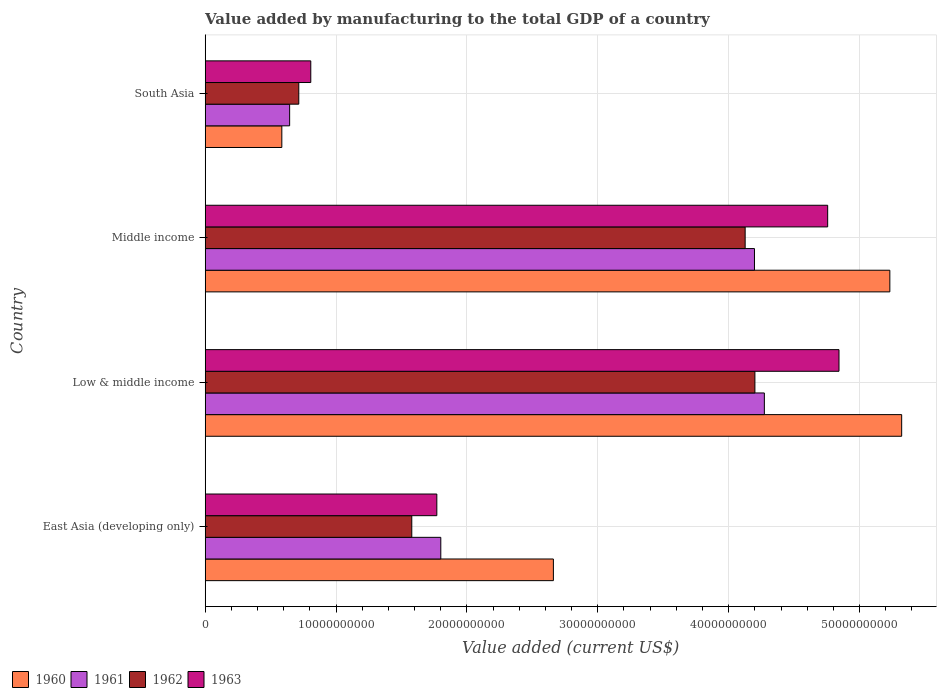How many groups of bars are there?
Your response must be concise. 4. Are the number of bars on each tick of the Y-axis equal?
Your answer should be very brief. Yes. What is the label of the 4th group of bars from the top?
Make the answer very short. East Asia (developing only). What is the value added by manufacturing to the total GDP in 1962 in Middle income?
Provide a succinct answer. 4.13e+1. Across all countries, what is the maximum value added by manufacturing to the total GDP in 1961?
Provide a short and direct response. 4.27e+1. Across all countries, what is the minimum value added by manufacturing to the total GDP in 1961?
Offer a very short reply. 6.45e+09. In which country was the value added by manufacturing to the total GDP in 1960 minimum?
Ensure brevity in your answer.  South Asia. What is the total value added by manufacturing to the total GDP in 1963 in the graph?
Your response must be concise. 1.22e+11. What is the difference between the value added by manufacturing to the total GDP in 1961 in Low & middle income and that in Middle income?
Offer a very short reply. 7.56e+08. What is the difference between the value added by manufacturing to the total GDP in 1963 in Middle income and the value added by manufacturing to the total GDP in 1961 in Low & middle income?
Your answer should be compact. 4.84e+09. What is the average value added by manufacturing to the total GDP in 1960 per country?
Keep it short and to the point. 3.45e+1. What is the difference between the value added by manufacturing to the total GDP in 1962 and value added by manufacturing to the total GDP in 1961 in East Asia (developing only)?
Your answer should be very brief. -2.22e+09. What is the ratio of the value added by manufacturing to the total GDP in 1962 in Middle income to that in South Asia?
Your response must be concise. 5.77. What is the difference between the highest and the second highest value added by manufacturing to the total GDP in 1962?
Ensure brevity in your answer.  7.46e+08. What is the difference between the highest and the lowest value added by manufacturing to the total GDP in 1961?
Give a very brief answer. 3.63e+1. Is the sum of the value added by manufacturing to the total GDP in 1961 in Middle income and South Asia greater than the maximum value added by manufacturing to the total GDP in 1963 across all countries?
Your response must be concise. No. Is it the case that in every country, the sum of the value added by manufacturing to the total GDP in 1960 and value added by manufacturing to the total GDP in 1962 is greater than the sum of value added by manufacturing to the total GDP in 1961 and value added by manufacturing to the total GDP in 1963?
Make the answer very short. No. Is it the case that in every country, the sum of the value added by manufacturing to the total GDP in 1962 and value added by manufacturing to the total GDP in 1963 is greater than the value added by manufacturing to the total GDP in 1960?
Your answer should be very brief. Yes. How many countries are there in the graph?
Your answer should be compact. 4. What is the difference between two consecutive major ticks on the X-axis?
Your answer should be very brief. 1.00e+1. Are the values on the major ticks of X-axis written in scientific E-notation?
Provide a short and direct response. No. How many legend labels are there?
Offer a terse response. 4. What is the title of the graph?
Provide a short and direct response. Value added by manufacturing to the total GDP of a country. Does "1992" appear as one of the legend labels in the graph?
Provide a succinct answer. No. What is the label or title of the X-axis?
Offer a very short reply. Value added (current US$). What is the label or title of the Y-axis?
Offer a terse response. Country. What is the Value added (current US$) of 1960 in East Asia (developing only)?
Your answer should be very brief. 2.66e+1. What is the Value added (current US$) in 1961 in East Asia (developing only)?
Keep it short and to the point. 1.80e+1. What is the Value added (current US$) in 1962 in East Asia (developing only)?
Offer a terse response. 1.58e+1. What is the Value added (current US$) of 1963 in East Asia (developing only)?
Give a very brief answer. 1.77e+1. What is the Value added (current US$) in 1960 in Low & middle income?
Ensure brevity in your answer.  5.32e+1. What is the Value added (current US$) of 1961 in Low & middle income?
Your answer should be compact. 4.27e+1. What is the Value added (current US$) of 1962 in Low & middle income?
Your response must be concise. 4.20e+1. What is the Value added (current US$) in 1963 in Low & middle income?
Your response must be concise. 4.84e+1. What is the Value added (current US$) of 1960 in Middle income?
Provide a short and direct response. 5.23e+1. What is the Value added (current US$) of 1961 in Middle income?
Provide a succinct answer. 4.20e+1. What is the Value added (current US$) in 1962 in Middle income?
Your response must be concise. 4.13e+1. What is the Value added (current US$) of 1963 in Middle income?
Keep it short and to the point. 4.76e+1. What is the Value added (current US$) in 1960 in South Asia?
Your answer should be very brief. 5.86e+09. What is the Value added (current US$) of 1961 in South Asia?
Provide a short and direct response. 6.45e+09. What is the Value added (current US$) of 1962 in South Asia?
Your answer should be compact. 7.15e+09. What is the Value added (current US$) of 1963 in South Asia?
Give a very brief answer. 8.07e+09. Across all countries, what is the maximum Value added (current US$) in 1960?
Your answer should be compact. 5.32e+1. Across all countries, what is the maximum Value added (current US$) of 1961?
Your answer should be very brief. 4.27e+1. Across all countries, what is the maximum Value added (current US$) in 1962?
Provide a succinct answer. 4.20e+1. Across all countries, what is the maximum Value added (current US$) of 1963?
Provide a short and direct response. 4.84e+1. Across all countries, what is the minimum Value added (current US$) of 1960?
Give a very brief answer. 5.86e+09. Across all countries, what is the minimum Value added (current US$) in 1961?
Keep it short and to the point. 6.45e+09. Across all countries, what is the minimum Value added (current US$) of 1962?
Provide a succinct answer. 7.15e+09. Across all countries, what is the minimum Value added (current US$) of 1963?
Offer a very short reply. 8.07e+09. What is the total Value added (current US$) of 1960 in the graph?
Offer a very short reply. 1.38e+11. What is the total Value added (current US$) in 1961 in the graph?
Your answer should be compact. 1.09e+11. What is the total Value added (current US$) of 1962 in the graph?
Ensure brevity in your answer.  1.06e+11. What is the total Value added (current US$) in 1963 in the graph?
Your response must be concise. 1.22e+11. What is the difference between the Value added (current US$) of 1960 in East Asia (developing only) and that in Low & middle income?
Provide a short and direct response. -2.66e+1. What is the difference between the Value added (current US$) in 1961 in East Asia (developing only) and that in Low & middle income?
Keep it short and to the point. -2.47e+1. What is the difference between the Value added (current US$) of 1962 in East Asia (developing only) and that in Low & middle income?
Your answer should be compact. -2.62e+1. What is the difference between the Value added (current US$) of 1963 in East Asia (developing only) and that in Low & middle income?
Your answer should be very brief. -3.07e+1. What is the difference between the Value added (current US$) in 1960 in East Asia (developing only) and that in Middle income?
Provide a short and direct response. -2.57e+1. What is the difference between the Value added (current US$) in 1961 in East Asia (developing only) and that in Middle income?
Your answer should be very brief. -2.40e+1. What is the difference between the Value added (current US$) in 1962 in East Asia (developing only) and that in Middle income?
Your answer should be very brief. -2.55e+1. What is the difference between the Value added (current US$) in 1963 in East Asia (developing only) and that in Middle income?
Offer a terse response. -2.99e+1. What is the difference between the Value added (current US$) in 1960 in East Asia (developing only) and that in South Asia?
Provide a succinct answer. 2.08e+1. What is the difference between the Value added (current US$) of 1961 in East Asia (developing only) and that in South Asia?
Your response must be concise. 1.16e+1. What is the difference between the Value added (current US$) in 1962 in East Asia (developing only) and that in South Asia?
Keep it short and to the point. 8.63e+09. What is the difference between the Value added (current US$) in 1963 in East Asia (developing only) and that in South Asia?
Give a very brief answer. 9.63e+09. What is the difference between the Value added (current US$) of 1960 in Low & middle income and that in Middle income?
Provide a short and direct response. 9.04e+08. What is the difference between the Value added (current US$) of 1961 in Low & middle income and that in Middle income?
Ensure brevity in your answer.  7.56e+08. What is the difference between the Value added (current US$) of 1962 in Low & middle income and that in Middle income?
Give a very brief answer. 7.46e+08. What is the difference between the Value added (current US$) in 1963 in Low & middle income and that in Middle income?
Provide a succinct answer. 8.65e+08. What is the difference between the Value added (current US$) of 1960 in Low & middle income and that in South Asia?
Make the answer very short. 4.74e+1. What is the difference between the Value added (current US$) of 1961 in Low & middle income and that in South Asia?
Provide a short and direct response. 3.63e+1. What is the difference between the Value added (current US$) in 1962 in Low & middle income and that in South Asia?
Make the answer very short. 3.49e+1. What is the difference between the Value added (current US$) of 1963 in Low & middle income and that in South Asia?
Give a very brief answer. 4.04e+1. What is the difference between the Value added (current US$) in 1960 in Middle income and that in South Asia?
Your answer should be compact. 4.65e+1. What is the difference between the Value added (current US$) of 1961 in Middle income and that in South Asia?
Your response must be concise. 3.55e+1. What is the difference between the Value added (current US$) in 1962 in Middle income and that in South Asia?
Give a very brief answer. 3.41e+1. What is the difference between the Value added (current US$) of 1963 in Middle income and that in South Asia?
Offer a very short reply. 3.95e+1. What is the difference between the Value added (current US$) in 1960 in East Asia (developing only) and the Value added (current US$) in 1961 in Low & middle income?
Provide a succinct answer. -1.61e+1. What is the difference between the Value added (current US$) in 1960 in East Asia (developing only) and the Value added (current US$) in 1962 in Low & middle income?
Offer a very short reply. -1.54e+1. What is the difference between the Value added (current US$) in 1960 in East Asia (developing only) and the Value added (current US$) in 1963 in Low & middle income?
Offer a terse response. -2.18e+1. What is the difference between the Value added (current US$) of 1961 in East Asia (developing only) and the Value added (current US$) of 1962 in Low & middle income?
Provide a succinct answer. -2.40e+1. What is the difference between the Value added (current US$) of 1961 in East Asia (developing only) and the Value added (current US$) of 1963 in Low & middle income?
Keep it short and to the point. -3.04e+1. What is the difference between the Value added (current US$) in 1962 in East Asia (developing only) and the Value added (current US$) in 1963 in Low & middle income?
Make the answer very short. -3.26e+1. What is the difference between the Value added (current US$) in 1960 in East Asia (developing only) and the Value added (current US$) in 1961 in Middle income?
Ensure brevity in your answer.  -1.54e+1. What is the difference between the Value added (current US$) in 1960 in East Asia (developing only) and the Value added (current US$) in 1962 in Middle income?
Keep it short and to the point. -1.47e+1. What is the difference between the Value added (current US$) in 1960 in East Asia (developing only) and the Value added (current US$) in 1963 in Middle income?
Your response must be concise. -2.10e+1. What is the difference between the Value added (current US$) in 1961 in East Asia (developing only) and the Value added (current US$) in 1962 in Middle income?
Keep it short and to the point. -2.33e+1. What is the difference between the Value added (current US$) of 1961 in East Asia (developing only) and the Value added (current US$) of 1963 in Middle income?
Your response must be concise. -2.96e+1. What is the difference between the Value added (current US$) of 1962 in East Asia (developing only) and the Value added (current US$) of 1963 in Middle income?
Ensure brevity in your answer.  -3.18e+1. What is the difference between the Value added (current US$) of 1960 in East Asia (developing only) and the Value added (current US$) of 1961 in South Asia?
Your response must be concise. 2.02e+1. What is the difference between the Value added (current US$) of 1960 in East Asia (developing only) and the Value added (current US$) of 1962 in South Asia?
Your response must be concise. 1.95e+1. What is the difference between the Value added (current US$) of 1960 in East Asia (developing only) and the Value added (current US$) of 1963 in South Asia?
Ensure brevity in your answer.  1.85e+1. What is the difference between the Value added (current US$) in 1961 in East Asia (developing only) and the Value added (current US$) in 1962 in South Asia?
Provide a succinct answer. 1.09e+1. What is the difference between the Value added (current US$) in 1961 in East Asia (developing only) and the Value added (current US$) in 1963 in South Asia?
Your response must be concise. 9.94e+09. What is the difference between the Value added (current US$) of 1962 in East Asia (developing only) and the Value added (current US$) of 1963 in South Asia?
Make the answer very short. 7.72e+09. What is the difference between the Value added (current US$) in 1960 in Low & middle income and the Value added (current US$) in 1961 in Middle income?
Keep it short and to the point. 1.12e+1. What is the difference between the Value added (current US$) of 1960 in Low & middle income and the Value added (current US$) of 1962 in Middle income?
Your answer should be compact. 1.20e+1. What is the difference between the Value added (current US$) in 1960 in Low & middle income and the Value added (current US$) in 1963 in Middle income?
Provide a succinct answer. 5.65e+09. What is the difference between the Value added (current US$) in 1961 in Low & middle income and the Value added (current US$) in 1962 in Middle income?
Give a very brief answer. 1.47e+09. What is the difference between the Value added (current US$) in 1961 in Low & middle income and the Value added (current US$) in 1963 in Middle income?
Provide a succinct answer. -4.84e+09. What is the difference between the Value added (current US$) of 1962 in Low & middle income and the Value added (current US$) of 1963 in Middle income?
Your response must be concise. -5.56e+09. What is the difference between the Value added (current US$) of 1960 in Low & middle income and the Value added (current US$) of 1961 in South Asia?
Your answer should be very brief. 4.68e+1. What is the difference between the Value added (current US$) of 1960 in Low & middle income and the Value added (current US$) of 1962 in South Asia?
Make the answer very short. 4.61e+1. What is the difference between the Value added (current US$) in 1960 in Low & middle income and the Value added (current US$) in 1963 in South Asia?
Give a very brief answer. 4.52e+1. What is the difference between the Value added (current US$) in 1961 in Low & middle income and the Value added (current US$) in 1962 in South Asia?
Provide a succinct answer. 3.56e+1. What is the difference between the Value added (current US$) in 1961 in Low & middle income and the Value added (current US$) in 1963 in South Asia?
Your response must be concise. 3.47e+1. What is the difference between the Value added (current US$) of 1962 in Low & middle income and the Value added (current US$) of 1963 in South Asia?
Provide a succinct answer. 3.39e+1. What is the difference between the Value added (current US$) in 1960 in Middle income and the Value added (current US$) in 1961 in South Asia?
Make the answer very short. 4.59e+1. What is the difference between the Value added (current US$) in 1960 in Middle income and the Value added (current US$) in 1962 in South Asia?
Provide a succinct answer. 4.52e+1. What is the difference between the Value added (current US$) of 1960 in Middle income and the Value added (current US$) of 1963 in South Asia?
Give a very brief answer. 4.42e+1. What is the difference between the Value added (current US$) of 1961 in Middle income and the Value added (current US$) of 1962 in South Asia?
Provide a succinct answer. 3.48e+1. What is the difference between the Value added (current US$) of 1961 in Middle income and the Value added (current US$) of 1963 in South Asia?
Your response must be concise. 3.39e+1. What is the difference between the Value added (current US$) in 1962 in Middle income and the Value added (current US$) in 1963 in South Asia?
Provide a succinct answer. 3.32e+1. What is the average Value added (current US$) of 1960 per country?
Offer a very short reply. 3.45e+1. What is the average Value added (current US$) in 1961 per country?
Your answer should be very brief. 2.73e+1. What is the average Value added (current US$) of 1962 per country?
Your answer should be very brief. 2.66e+1. What is the average Value added (current US$) in 1963 per country?
Provide a short and direct response. 3.04e+1. What is the difference between the Value added (current US$) in 1960 and Value added (current US$) in 1961 in East Asia (developing only)?
Provide a succinct answer. 8.60e+09. What is the difference between the Value added (current US$) of 1960 and Value added (current US$) of 1962 in East Asia (developing only)?
Offer a terse response. 1.08e+1. What is the difference between the Value added (current US$) in 1960 and Value added (current US$) in 1963 in East Asia (developing only)?
Offer a terse response. 8.91e+09. What is the difference between the Value added (current US$) in 1961 and Value added (current US$) in 1962 in East Asia (developing only)?
Keep it short and to the point. 2.22e+09. What is the difference between the Value added (current US$) in 1961 and Value added (current US$) in 1963 in East Asia (developing only)?
Ensure brevity in your answer.  3.04e+08. What is the difference between the Value added (current US$) of 1962 and Value added (current US$) of 1963 in East Asia (developing only)?
Your response must be concise. -1.91e+09. What is the difference between the Value added (current US$) in 1960 and Value added (current US$) in 1961 in Low & middle income?
Your response must be concise. 1.05e+1. What is the difference between the Value added (current US$) in 1960 and Value added (current US$) in 1962 in Low & middle income?
Provide a short and direct response. 1.12e+1. What is the difference between the Value added (current US$) in 1960 and Value added (current US$) in 1963 in Low & middle income?
Make the answer very short. 4.79e+09. What is the difference between the Value added (current US$) of 1961 and Value added (current US$) of 1962 in Low & middle income?
Give a very brief answer. 7.22e+08. What is the difference between the Value added (current US$) of 1961 and Value added (current US$) of 1963 in Low & middle income?
Offer a terse response. -5.70e+09. What is the difference between the Value added (current US$) in 1962 and Value added (current US$) in 1963 in Low & middle income?
Make the answer very short. -6.43e+09. What is the difference between the Value added (current US$) of 1960 and Value added (current US$) of 1961 in Middle income?
Make the answer very short. 1.03e+1. What is the difference between the Value added (current US$) in 1960 and Value added (current US$) in 1962 in Middle income?
Your answer should be compact. 1.11e+1. What is the difference between the Value added (current US$) in 1960 and Value added (current US$) in 1963 in Middle income?
Your answer should be very brief. 4.75e+09. What is the difference between the Value added (current US$) in 1961 and Value added (current US$) in 1962 in Middle income?
Provide a succinct answer. 7.12e+08. What is the difference between the Value added (current US$) in 1961 and Value added (current US$) in 1963 in Middle income?
Offer a very short reply. -5.59e+09. What is the difference between the Value added (current US$) in 1962 and Value added (current US$) in 1963 in Middle income?
Give a very brief answer. -6.31e+09. What is the difference between the Value added (current US$) in 1960 and Value added (current US$) in 1961 in South Asia?
Provide a succinct answer. -5.98e+08. What is the difference between the Value added (current US$) of 1960 and Value added (current US$) of 1962 in South Asia?
Your response must be concise. -1.30e+09. What is the difference between the Value added (current US$) of 1960 and Value added (current US$) of 1963 in South Asia?
Ensure brevity in your answer.  -2.21e+09. What is the difference between the Value added (current US$) of 1961 and Value added (current US$) of 1962 in South Asia?
Provide a succinct answer. -6.98e+08. What is the difference between the Value added (current US$) of 1961 and Value added (current US$) of 1963 in South Asia?
Provide a succinct answer. -1.61e+09. What is the difference between the Value added (current US$) of 1962 and Value added (current US$) of 1963 in South Asia?
Offer a terse response. -9.17e+08. What is the ratio of the Value added (current US$) in 1960 in East Asia (developing only) to that in Low & middle income?
Provide a succinct answer. 0.5. What is the ratio of the Value added (current US$) in 1961 in East Asia (developing only) to that in Low & middle income?
Your answer should be compact. 0.42. What is the ratio of the Value added (current US$) of 1962 in East Asia (developing only) to that in Low & middle income?
Give a very brief answer. 0.38. What is the ratio of the Value added (current US$) in 1963 in East Asia (developing only) to that in Low & middle income?
Offer a terse response. 0.37. What is the ratio of the Value added (current US$) of 1960 in East Asia (developing only) to that in Middle income?
Give a very brief answer. 0.51. What is the ratio of the Value added (current US$) in 1961 in East Asia (developing only) to that in Middle income?
Make the answer very short. 0.43. What is the ratio of the Value added (current US$) of 1962 in East Asia (developing only) to that in Middle income?
Your answer should be very brief. 0.38. What is the ratio of the Value added (current US$) in 1963 in East Asia (developing only) to that in Middle income?
Offer a very short reply. 0.37. What is the ratio of the Value added (current US$) of 1960 in East Asia (developing only) to that in South Asia?
Your answer should be compact. 4.54. What is the ratio of the Value added (current US$) in 1961 in East Asia (developing only) to that in South Asia?
Offer a terse response. 2.79. What is the ratio of the Value added (current US$) of 1962 in East Asia (developing only) to that in South Asia?
Provide a short and direct response. 2.21. What is the ratio of the Value added (current US$) of 1963 in East Asia (developing only) to that in South Asia?
Give a very brief answer. 2.19. What is the ratio of the Value added (current US$) of 1960 in Low & middle income to that in Middle income?
Your response must be concise. 1.02. What is the ratio of the Value added (current US$) in 1962 in Low & middle income to that in Middle income?
Your response must be concise. 1.02. What is the ratio of the Value added (current US$) in 1963 in Low & middle income to that in Middle income?
Your answer should be very brief. 1.02. What is the ratio of the Value added (current US$) in 1960 in Low & middle income to that in South Asia?
Ensure brevity in your answer.  9.09. What is the ratio of the Value added (current US$) of 1961 in Low & middle income to that in South Asia?
Make the answer very short. 6.62. What is the ratio of the Value added (current US$) in 1962 in Low & middle income to that in South Asia?
Provide a short and direct response. 5.87. What is the ratio of the Value added (current US$) in 1963 in Low & middle income to that in South Asia?
Your answer should be very brief. 6. What is the ratio of the Value added (current US$) of 1960 in Middle income to that in South Asia?
Your answer should be compact. 8.93. What is the ratio of the Value added (current US$) of 1961 in Middle income to that in South Asia?
Your answer should be very brief. 6.5. What is the ratio of the Value added (current US$) in 1962 in Middle income to that in South Asia?
Offer a terse response. 5.77. What is the ratio of the Value added (current US$) in 1963 in Middle income to that in South Asia?
Provide a short and direct response. 5.9. What is the difference between the highest and the second highest Value added (current US$) of 1960?
Provide a succinct answer. 9.04e+08. What is the difference between the highest and the second highest Value added (current US$) of 1961?
Give a very brief answer. 7.56e+08. What is the difference between the highest and the second highest Value added (current US$) in 1962?
Offer a terse response. 7.46e+08. What is the difference between the highest and the second highest Value added (current US$) of 1963?
Your response must be concise. 8.65e+08. What is the difference between the highest and the lowest Value added (current US$) in 1960?
Ensure brevity in your answer.  4.74e+1. What is the difference between the highest and the lowest Value added (current US$) of 1961?
Ensure brevity in your answer.  3.63e+1. What is the difference between the highest and the lowest Value added (current US$) in 1962?
Provide a succinct answer. 3.49e+1. What is the difference between the highest and the lowest Value added (current US$) in 1963?
Offer a terse response. 4.04e+1. 